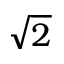<formula> <loc_0><loc_0><loc_500><loc_500>\sqrt { 2 }</formula> 